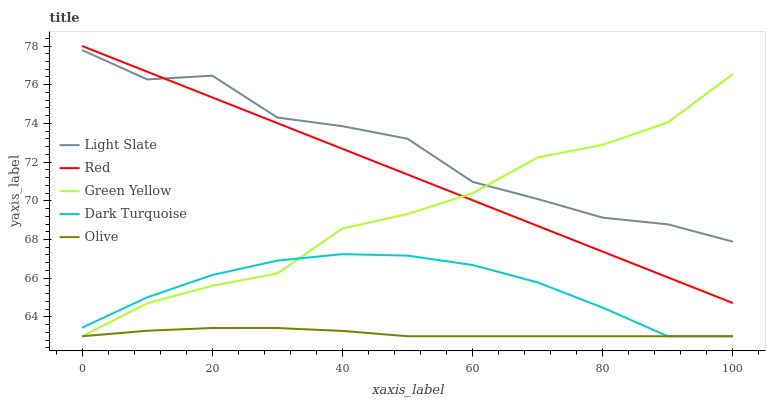Does Dark Turquoise have the minimum area under the curve?
Answer yes or no. No. Does Dark Turquoise have the maximum area under the curve?
Answer yes or no. No. Is Dark Turquoise the smoothest?
Answer yes or no. No. Is Dark Turquoise the roughest?
Answer yes or no. No. Does Red have the lowest value?
Answer yes or no. No. Does Dark Turquoise have the highest value?
Answer yes or no. No. Is Olive less than Light Slate?
Answer yes or no. Yes. Is Red greater than Olive?
Answer yes or no. Yes. Does Olive intersect Light Slate?
Answer yes or no. No. 